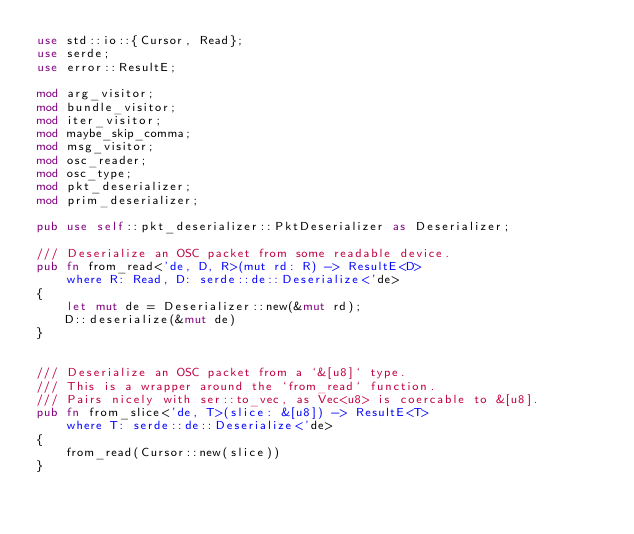Convert code to text. <code><loc_0><loc_0><loc_500><loc_500><_Rust_>use std::io::{Cursor, Read};
use serde;
use error::ResultE;

mod arg_visitor;
mod bundle_visitor;
mod iter_visitor;
mod maybe_skip_comma;
mod msg_visitor;
mod osc_reader;
mod osc_type;
mod pkt_deserializer;
mod prim_deserializer;

pub use self::pkt_deserializer::PktDeserializer as Deserializer;

/// Deserialize an OSC packet from some readable device.
pub fn from_read<'de, D, R>(mut rd: R) -> ResultE<D>
    where R: Read, D: serde::de::Deserialize<'de>
{
    let mut de = Deserializer::new(&mut rd);
    D::deserialize(&mut de)
}


/// Deserialize an OSC packet from a `&[u8]` type.
/// This is a wrapper around the `from_read` function.
/// Pairs nicely with ser::to_vec, as Vec<u8> is coercable to &[u8].
pub fn from_slice<'de, T>(slice: &[u8]) -> ResultE<T>
    where T: serde::de::Deserialize<'de>
{
    from_read(Cursor::new(slice))
}
</code> 